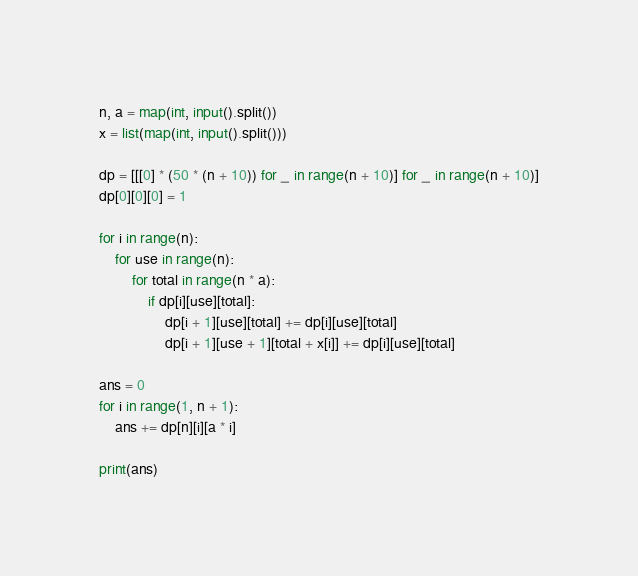Convert code to text. <code><loc_0><loc_0><loc_500><loc_500><_Python_>n, a = map(int, input().split())
x = list(map(int, input().split()))

dp = [[[0] * (50 * (n + 10)) for _ in range(n + 10)] for _ in range(n + 10)]
dp[0][0][0] = 1

for i in range(n):
    for use in range(n):
        for total in range(n * a):
            if dp[i][use][total]:
                dp[i + 1][use][total] += dp[i][use][total]
                dp[i + 1][use + 1][total + x[i]] += dp[i][use][total]

ans = 0
for i in range(1, n + 1):
    ans += dp[n][i][a * i]

print(ans)
</code> 